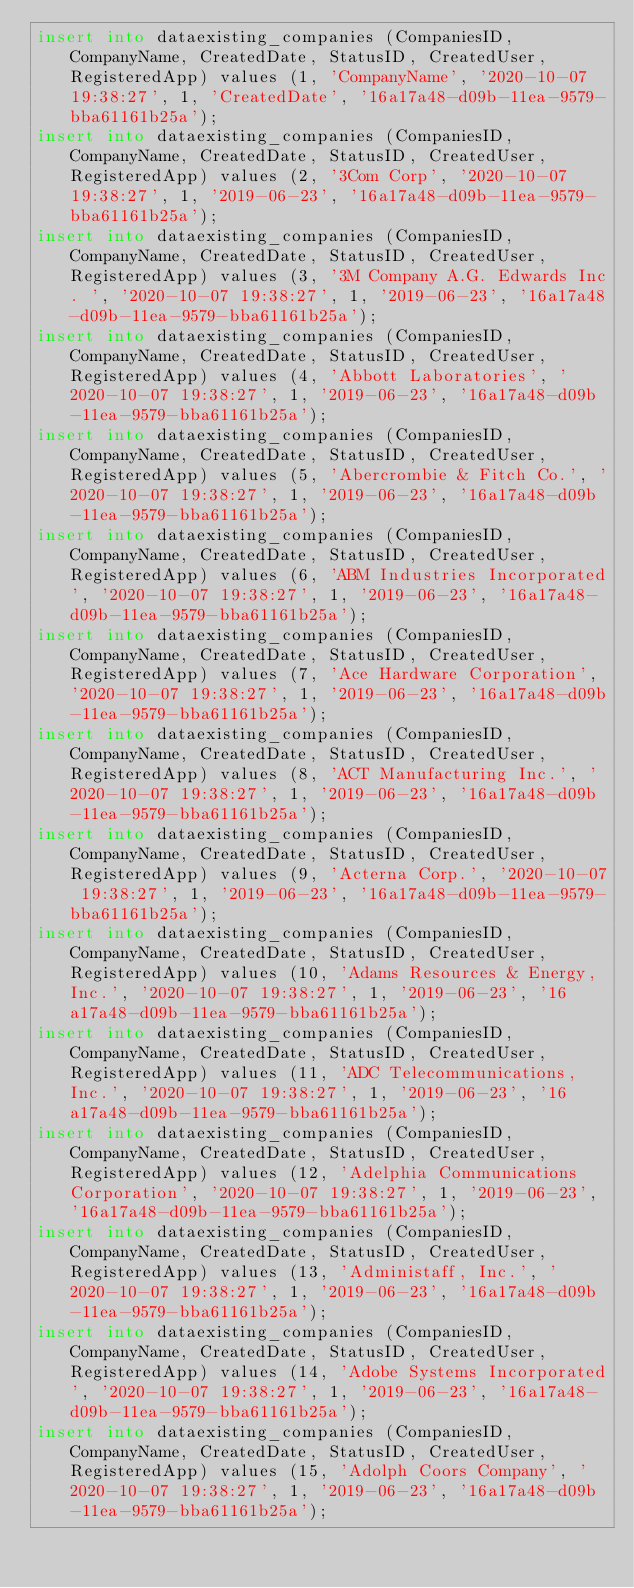<code> <loc_0><loc_0><loc_500><loc_500><_SQL_>insert into dataexisting_companies (CompaniesID, CompanyName, CreatedDate, StatusID, CreatedUser, RegisteredApp) values (1, 'CompanyName', '2020-10-07 19:38:27', 1, 'CreatedDate', '16a17a48-d09b-11ea-9579-bba61161b25a');
insert into dataexisting_companies (CompaniesID, CompanyName, CreatedDate, StatusID, CreatedUser, RegisteredApp) values (2, '3Com Corp', '2020-10-07 19:38:27', 1, '2019-06-23', '16a17a48-d09b-11ea-9579-bba61161b25a');
insert into dataexisting_companies (CompaniesID, CompanyName, CreatedDate, StatusID, CreatedUser, RegisteredApp) values (3, '3M Company A.G. Edwards Inc. ', '2020-10-07 19:38:27', 1, '2019-06-23', '16a17a48-d09b-11ea-9579-bba61161b25a');
insert into dataexisting_companies (CompaniesID, CompanyName, CreatedDate, StatusID, CreatedUser, RegisteredApp) values (4, 'Abbott Laboratories', '2020-10-07 19:38:27', 1, '2019-06-23', '16a17a48-d09b-11ea-9579-bba61161b25a');
insert into dataexisting_companies (CompaniesID, CompanyName, CreatedDate, StatusID, CreatedUser, RegisteredApp) values (5, 'Abercrombie & Fitch Co.', '2020-10-07 19:38:27', 1, '2019-06-23', '16a17a48-d09b-11ea-9579-bba61161b25a');
insert into dataexisting_companies (CompaniesID, CompanyName, CreatedDate, StatusID, CreatedUser, RegisteredApp) values (6, 'ABM Industries Incorporated', '2020-10-07 19:38:27', 1, '2019-06-23', '16a17a48-d09b-11ea-9579-bba61161b25a');
insert into dataexisting_companies (CompaniesID, CompanyName, CreatedDate, StatusID, CreatedUser, RegisteredApp) values (7, 'Ace Hardware Corporation', '2020-10-07 19:38:27', 1, '2019-06-23', '16a17a48-d09b-11ea-9579-bba61161b25a');
insert into dataexisting_companies (CompaniesID, CompanyName, CreatedDate, StatusID, CreatedUser, RegisteredApp) values (8, 'ACT Manufacturing Inc.', '2020-10-07 19:38:27', 1, '2019-06-23', '16a17a48-d09b-11ea-9579-bba61161b25a');
insert into dataexisting_companies (CompaniesID, CompanyName, CreatedDate, StatusID, CreatedUser, RegisteredApp) values (9, 'Acterna Corp.', '2020-10-07 19:38:27', 1, '2019-06-23', '16a17a48-d09b-11ea-9579-bba61161b25a');
insert into dataexisting_companies (CompaniesID, CompanyName, CreatedDate, StatusID, CreatedUser, RegisteredApp) values (10, 'Adams Resources & Energy, Inc.', '2020-10-07 19:38:27', 1, '2019-06-23', '16a17a48-d09b-11ea-9579-bba61161b25a');
insert into dataexisting_companies (CompaniesID, CompanyName, CreatedDate, StatusID, CreatedUser, RegisteredApp) values (11, 'ADC Telecommunications, Inc.', '2020-10-07 19:38:27', 1, '2019-06-23', '16a17a48-d09b-11ea-9579-bba61161b25a');
insert into dataexisting_companies (CompaniesID, CompanyName, CreatedDate, StatusID, CreatedUser, RegisteredApp) values (12, 'Adelphia Communications Corporation', '2020-10-07 19:38:27', 1, '2019-06-23', '16a17a48-d09b-11ea-9579-bba61161b25a');
insert into dataexisting_companies (CompaniesID, CompanyName, CreatedDate, StatusID, CreatedUser, RegisteredApp) values (13, 'Administaff, Inc.', '2020-10-07 19:38:27', 1, '2019-06-23', '16a17a48-d09b-11ea-9579-bba61161b25a');
insert into dataexisting_companies (CompaniesID, CompanyName, CreatedDate, StatusID, CreatedUser, RegisteredApp) values (14, 'Adobe Systems Incorporated', '2020-10-07 19:38:27', 1, '2019-06-23', '16a17a48-d09b-11ea-9579-bba61161b25a');
insert into dataexisting_companies (CompaniesID, CompanyName, CreatedDate, StatusID, CreatedUser, RegisteredApp) values (15, 'Adolph Coors Company', '2020-10-07 19:38:27', 1, '2019-06-23', '16a17a48-d09b-11ea-9579-bba61161b25a');</code> 